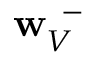Convert formula to latex. <formula><loc_0><loc_0><loc_500><loc_500>{ w } _ { V } ^ { \, - }</formula> 